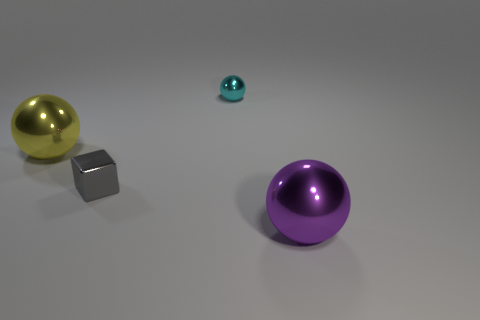What is the possible material of the small teal ball compared to the other objects? The small teal ball has a less reflective, more diffuse appearance, which may suggest a material like plastic or matte paint, whereas the other objects, such as the large purple ball and the gray cube, seem to be made of materials with higher gloss and reflectivity, perhaps metal or polished stone. 